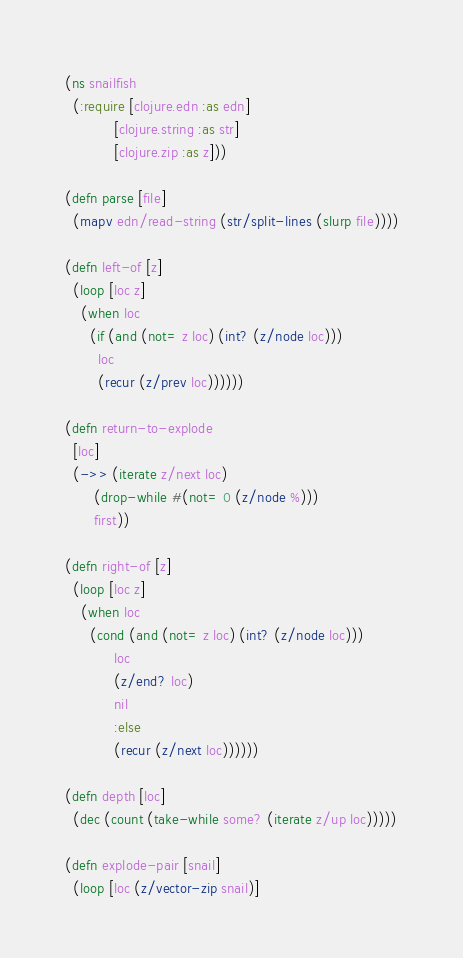Convert code to text. <code><loc_0><loc_0><loc_500><loc_500><_Clojure_>(ns snailfish
  (:require [clojure.edn :as edn]
            [clojure.string :as str]
            [clojure.zip :as z]))

(defn parse [file]
  (mapv edn/read-string (str/split-lines (slurp file))))

(defn left-of [z]
  (loop [loc z]
    (when loc
      (if (and (not= z loc) (int? (z/node loc)))
        loc
        (recur (z/prev loc))))))

(defn return-to-explode
  [loc]
  (->> (iterate z/next loc)
       (drop-while #(not= 0 (z/node %)))
       first))

(defn right-of [z]
  (loop [loc z]
    (when loc
      (cond (and (not= z loc) (int? (z/node loc)))
            loc
            (z/end? loc)
            nil
            :else
            (recur (z/next loc))))))

(defn depth [loc]
  (dec (count (take-while some? (iterate z/up loc)))))

(defn explode-pair [snail]
  (loop [loc (z/vector-zip snail)]</code> 